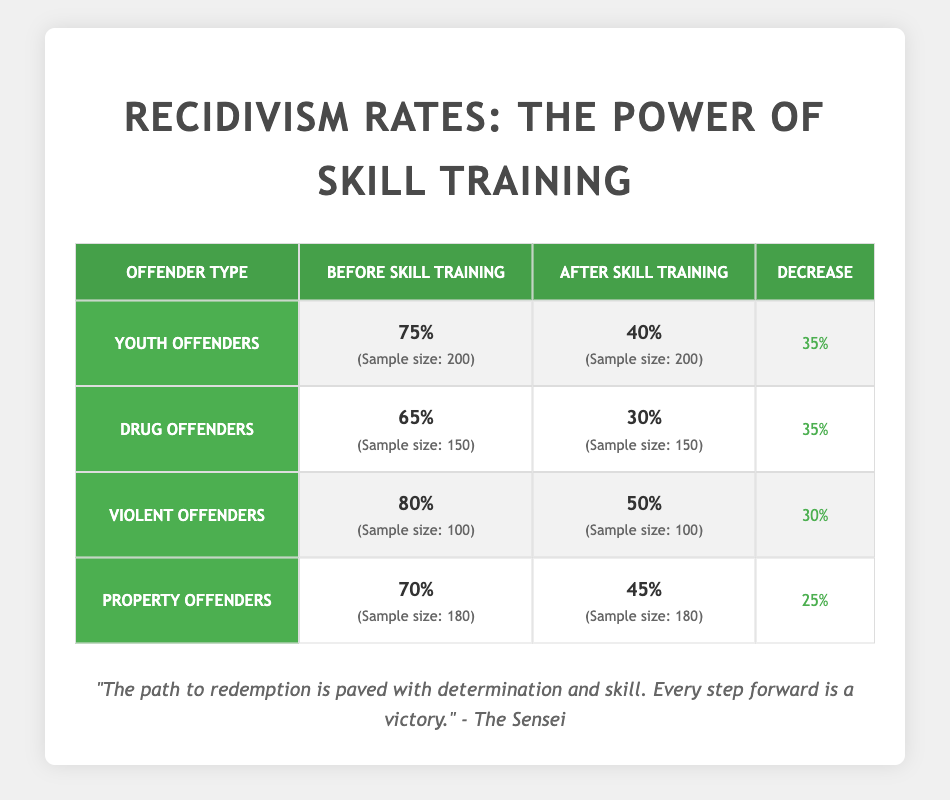What was the recidivism rate for youth offenders before skill training? The table states that the recidivism rate for youth offenders before skill training was 75%.
Answer: 75% What was the decrease in recidivism rates for drug offenders after skill training? The recidivism rate for drug offenders before skill training was 65%, and after skill training, it was 30%. The difference is calculated as 65% - 30% = 35%.
Answer: 35% Did the recidivism rate for property offenders decrease by more than 30% after skill training? The recidivism rate for property offenders before training was 70%, and after training, it was 45%. The decrease is 70% - 45% = 25%, which is not more than 30%.
Answer: No What is the average recidivism rate for all offender types after skill training? The rates after skill training for all offender types are: youth - 40%, drug - 30%, violent - 50%, and property - 45%. Summing these (40 + 30 + 50 + 45 = 165) and dividing by the number of types (4) gives an average of 165 / 4 = 41.25%.
Answer: 41.25% Which type of offender showed the largest percentage decrease in recidivism rates after skill training? The decreases were: youth offenders = 35%, drug offenders = 35%, violent offenders = 30%, property offenders = 25%. Youth and drug offenders both had the largest decrease of 35%.
Answer: Youth and drug offenders What was the sample size for violent offenders before skill training? The table specifies that the sample size for violent offenders before skill training was 100.
Answer: 100 Was the recidivism rate for drug offenders lower after skill training compared to the rate for youth offenders before skill training? The drug offenders' rate after training was 30%, whereas youth offenders' rate before training was 75%. Since 30% is lower than 75%, the statement is true.
Answer: Yes What was the combined recidivism rate for youth and property offenders before skill training? The rates before skill training were 75% for youth offenders and 70% for property offenders. Their combined rate is calculated as (75 + 70) = 145%.
Answer: 145% 